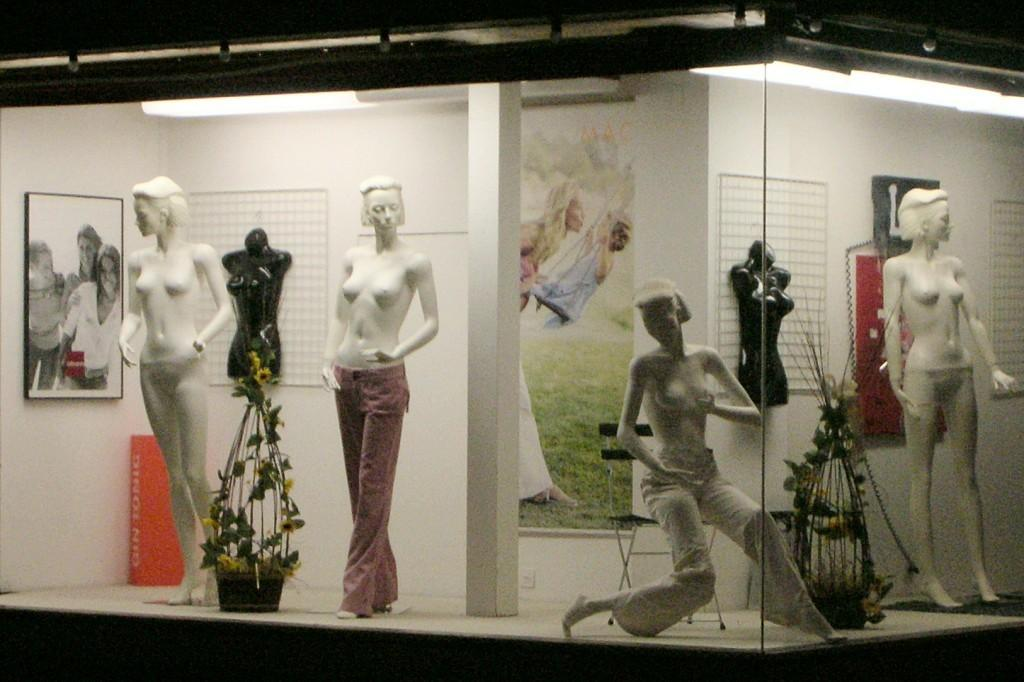What type of objects are in the image? There are mannequins in the image. How are the mannequins positioned? Some mannequins are standing, while one is sitting on a chair. What other objects can be seen in the image? There are two flower pots and a pillar in the image. What is on the wall in the image? Frames are attached to a white wall in the image. How many chairs are in the middle of the image? There is no chair in the middle of the image; only a sitting mannequin on a chair is present. What type of weapon is attached to the pillar in the image? There is no weapon, such as a cannon, attached to the pillar in the image. 